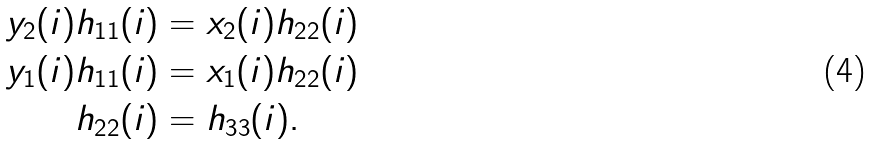<formula> <loc_0><loc_0><loc_500><loc_500>y _ { 2 } ( i ) h _ { 1 1 } ( i ) & = x _ { 2 } ( i ) h _ { 2 2 } ( i ) \ \\ y _ { 1 } ( i ) h _ { 1 1 } ( i ) & = x _ { 1 } ( i ) h _ { 2 2 } ( i ) \\ h _ { 2 2 } ( i ) & = h _ { 3 3 } ( i ) .</formula> 